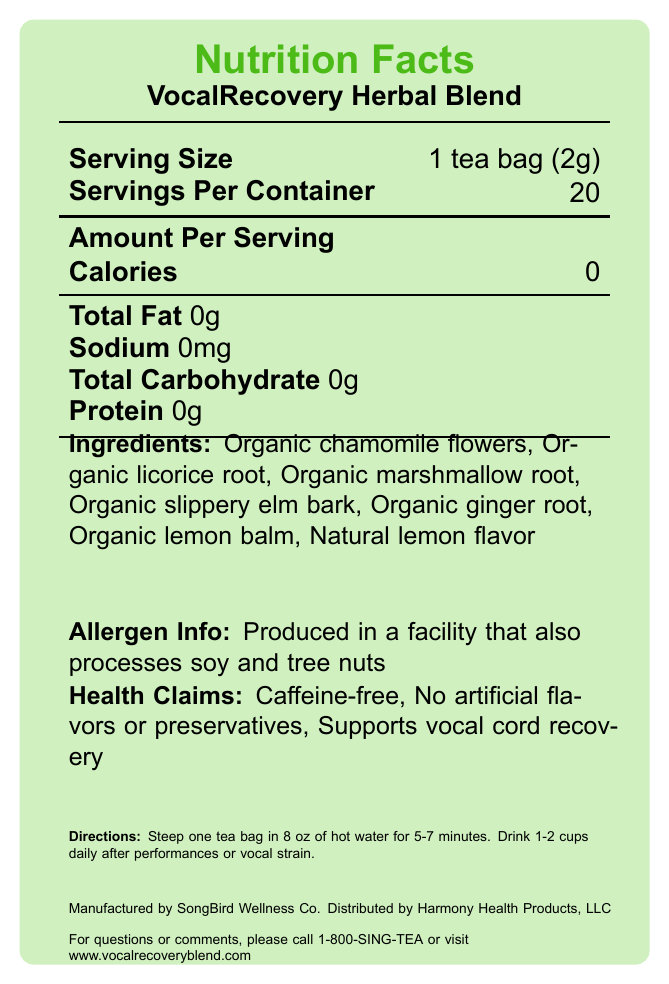what is the product name? The document specifies "VocalRecovery Herbal Blend" as the product name near the top.
Answer: VocalRecovery Herbal Blend how many servings are in one container? The "Servings Per Container" section states that there are 20 servings per container.
Answer: 20 what is the caffeine content of the product? The document states "Caffeine-free" as a health claim and "caffeine: 0mg" under additional info.
Answer: 0mg list the first three ingredients? The Ingredients section lists these as the first three ingredients.
Answer: Organic chamomile flowers, Organic licorice root, Organic marshmallow root who manufactures the product? The manufacturer is mentioned as "SongBird Wellness Co." at the bottom of the label.
Answer: SongBird Wellness Co. how should the tea be prepared? A. Boil water for 10 minutes B. Steep one tea bag in 8 oz of hot water for 5-7 minutes C. Add sugar and milk The directions state to steep one tea bag in 8 oz of hot water for 5-7 minutes.
Answer: B which certification does not apply to the product? A. USDA Organic B. Non-GMO Project Verified C. Fair Trade Certified The document lists "USDA Organic" and "Non-GMO Project Verified" as certifications, but not "Fair Trade Certified."
Answer: C is this product suitable for the gluten-sensitive population? The additional information section states "gluten-free."
Answer: Yes summarize the main idea of the document. The document is a detailed Nutrition Facts Label for VocalRecovery Herbal Blend, providing all necessary information for consumers about its usage and benefits.
Answer: The document provides nutritional information for a caffeine-free herbal tea blend called VocalRecovery Herbal Blend, designed to support vocal cord recovery. It includes details about serving size, ingredients, health claims, preparation instructions, manufacturer information, and certifications. what are the calories per serving? The "Amount Per Serving" section lists "Calories" as 0.
Answer: 0 can this tea help with vocal cord recovery? One of the health claims stated is "Supports vocal cord recovery."
Answer: Yes is the product intended to diagnose, treat, cure, or prevent any disease? The disclaimer at the bottom states that "This product is not intended to diagnose, treat, cure, or prevent any disease."
Answer: No when might you drink this tea? The directions suggest drinking the tea after performances or vocal strain.
Answer: After performances or vocal strain what ingredients might someone allergic to soy need to be aware of? The allergen information mentions that it is produced in a facility that processes soy and tree nuts, but it does not specify if the product contains these allergens.
Answer: Not enough information 